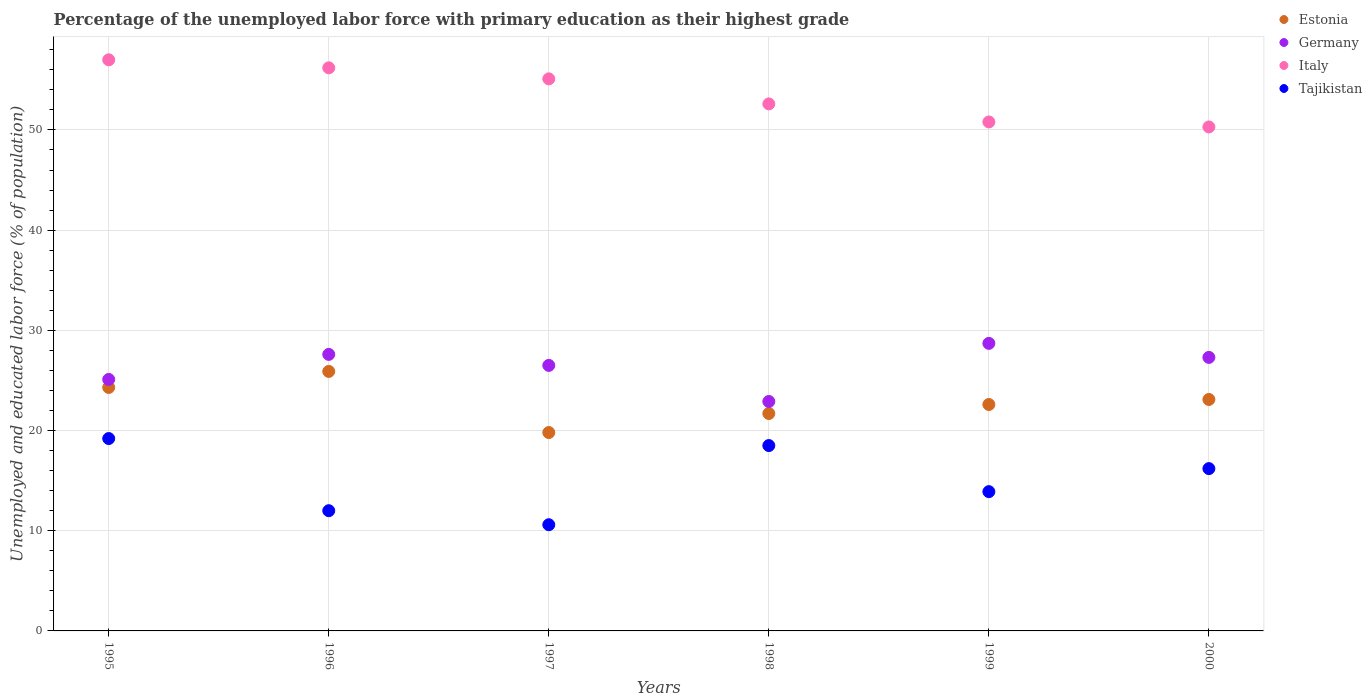How many different coloured dotlines are there?
Provide a succinct answer. 4. Is the number of dotlines equal to the number of legend labels?
Your answer should be compact. Yes. What is the percentage of the unemployed labor force with primary education in Tajikistan in 1999?
Your response must be concise. 13.9. Across all years, what is the maximum percentage of the unemployed labor force with primary education in Tajikistan?
Your response must be concise. 19.2. Across all years, what is the minimum percentage of the unemployed labor force with primary education in Germany?
Make the answer very short. 22.9. In which year was the percentage of the unemployed labor force with primary education in Germany minimum?
Your response must be concise. 1998. What is the total percentage of the unemployed labor force with primary education in Italy in the graph?
Your response must be concise. 322. What is the difference between the percentage of the unemployed labor force with primary education in Germany in 1995 and that in 1997?
Offer a terse response. -1.4. What is the difference between the percentage of the unemployed labor force with primary education in Germany in 1999 and the percentage of the unemployed labor force with primary education in Estonia in 1996?
Make the answer very short. 2.8. What is the average percentage of the unemployed labor force with primary education in Italy per year?
Your response must be concise. 53.67. In the year 2000, what is the difference between the percentage of the unemployed labor force with primary education in Italy and percentage of the unemployed labor force with primary education in Estonia?
Make the answer very short. 27.2. What is the ratio of the percentage of the unemployed labor force with primary education in Tajikistan in 1995 to that in 2000?
Provide a succinct answer. 1.19. What is the difference between the highest and the second highest percentage of the unemployed labor force with primary education in Estonia?
Offer a very short reply. 1.6. What is the difference between the highest and the lowest percentage of the unemployed labor force with primary education in Germany?
Your answer should be compact. 5.8. In how many years, is the percentage of the unemployed labor force with primary education in Tajikistan greater than the average percentage of the unemployed labor force with primary education in Tajikistan taken over all years?
Provide a succinct answer. 3. Is the percentage of the unemployed labor force with primary education in Estonia strictly greater than the percentage of the unemployed labor force with primary education in Tajikistan over the years?
Give a very brief answer. Yes. Is the percentage of the unemployed labor force with primary education in Germany strictly less than the percentage of the unemployed labor force with primary education in Tajikistan over the years?
Provide a succinct answer. No. Does the graph contain any zero values?
Give a very brief answer. No. How are the legend labels stacked?
Ensure brevity in your answer.  Vertical. What is the title of the graph?
Provide a succinct answer. Percentage of the unemployed labor force with primary education as their highest grade. What is the label or title of the X-axis?
Your answer should be very brief. Years. What is the label or title of the Y-axis?
Your response must be concise. Unemployed and educated labor force (% of population). What is the Unemployed and educated labor force (% of population) in Estonia in 1995?
Offer a terse response. 24.3. What is the Unemployed and educated labor force (% of population) in Germany in 1995?
Your answer should be compact. 25.1. What is the Unemployed and educated labor force (% of population) in Tajikistan in 1995?
Provide a short and direct response. 19.2. What is the Unemployed and educated labor force (% of population) in Estonia in 1996?
Your answer should be compact. 25.9. What is the Unemployed and educated labor force (% of population) in Germany in 1996?
Keep it short and to the point. 27.6. What is the Unemployed and educated labor force (% of population) in Italy in 1996?
Provide a short and direct response. 56.2. What is the Unemployed and educated labor force (% of population) in Estonia in 1997?
Offer a very short reply. 19.8. What is the Unemployed and educated labor force (% of population) of Italy in 1997?
Ensure brevity in your answer.  55.1. What is the Unemployed and educated labor force (% of population) of Tajikistan in 1997?
Keep it short and to the point. 10.6. What is the Unemployed and educated labor force (% of population) of Estonia in 1998?
Your answer should be very brief. 21.7. What is the Unemployed and educated labor force (% of population) of Germany in 1998?
Your answer should be compact. 22.9. What is the Unemployed and educated labor force (% of population) of Italy in 1998?
Offer a very short reply. 52.6. What is the Unemployed and educated labor force (% of population) of Estonia in 1999?
Provide a short and direct response. 22.6. What is the Unemployed and educated labor force (% of population) of Germany in 1999?
Ensure brevity in your answer.  28.7. What is the Unemployed and educated labor force (% of population) in Italy in 1999?
Your response must be concise. 50.8. What is the Unemployed and educated labor force (% of population) of Tajikistan in 1999?
Ensure brevity in your answer.  13.9. What is the Unemployed and educated labor force (% of population) of Estonia in 2000?
Make the answer very short. 23.1. What is the Unemployed and educated labor force (% of population) of Germany in 2000?
Ensure brevity in your answer.  27.3. What is the Unemployed and educated labor force (% of population) of Italy in 2000?
Make the answer very short. 50.3. What is the Unemployed and educated labor force (% of population) of Tajikistan in 2000?
Give a very brief answer. 16.2. Across all years, what is the maximum Unemployed and educated labor force (% of population) in Estonia?
Provide a succinct answer. 25.9. Across all years, what is the maximum Unemployed and educated labor force (% of population) in Germany?
Keep it short and to the point. 28.7. Across all years, what is the maximum Unemployed and educated labor force (% of population) in Tajikistan?
Your answer should be compact. 19.2. Across all years, what is the minimum Unemployed and educated labor force (% of population) of Estonia?
Give a very brief answer. 19.8. Across all years, what is the minimum Unemployed and educated labor force (% of population) of Germany?
Provide a short and direct response. 22.9. Across all years, what is the minimum Unemployed and educated labor force (% of population) of Italy?
Provide a short and direct response. 50.3. Across all years, what is the minimum Unemployed and educated labor force (% of population) in Tajikistan?
Make the answer very short. 10.6. What is the total Unemployed and educated labor force (% of population) in Estonia in the graph?
Make the answer very short. 137.4. What is the total Unemployed and educated labor force (% of population) in Germany in the graph?
Provide a short and direct response. 158.1. What is the total Unemployed and educated labor force (% of population) in Italy in the graph?
Keep it short and to the point. 322. What is the total Unemployed and educated labor force (% of population) of Tajikistan in the graph?
Your answer should be compact. 90.4. What is the difference between the Unemployed and educated labor force (% of population) in Estonia in 1995 and that in 1996?
Provide a succinct answer. -1.6. What is the difference between the Unemployed and educated labor force (% of population) in Estonia in 1995 and that in 1997?
Make the answer very short. 4.5. What is the difference between the Unemployed and educated labor force (% of population) of Tajikistan in 1995 and that in 1997?
Give a very brief answer. 8.6. What is the difference between the Unemployed and educated labor force (% of population) in Germany in 1995 and that in 1998?
Offer a very short reply. 2.2. What is the difference between the Unemployed and educated labor force (% of population) in Italy in 1995 and that in 1998?
Your response must be concise. 4.4. What is the difference between the Unemployed and educated labor force (% of population) of Tajikistan in 1995 and that in 1998?
Your response must be concise. 0.7. What is the difference between the Unemployed and educated labor force (% of population) in Italy in 1995 and that in 1999?
Provide a succinct answer. 6.2. What is the difference between the Unemployed and educated labor force (% of population) in Tajikistan in 1995 and that in 1999?
Ensure brevity in your answer.  5.3. What is the difference between the Unemployed and educated labor force (% of population) of Tajikistan in 1995 and that in 2000?
Your response must be concise. 3. What is the difference between the Unemployed and educated labor force (% of population) in Germany in 1996 and that in 1997?
Provide a short and direct response. 1.1. What is the difference between the Unemployed and educated labor force (% of population) of Italy in 1996 and that in 1997?
Provide a succinct answer. 1.1. What is the difference between the Unemployed and educated labor force (% of population) of Germany in 1996 and that in 1998?
Offer a terse response. 4.7. What is the difference between the Unemployed and educated labor force (% of population) in Estonia in 1996 and that in 1999?
Provide a short and direct response. 3.3. What is the difference between the Unemployed and educated labor force (% of population) in Germany in 1996 and that in 1999?
Offer a very short reply. -1.1. What is the difference between the Unemployed and educated labor force (% of population) in Estonia in 1996 and that in 2000?
Provide a short and direct response. 2.8. What is the difference between the Unemployed and educated labor force (% of population) of Italy in 1996 and that in 2000?
Offer a terse response. 5.9. What is the difference between the Unemployed and educated labor force (% of population) of Estonia in 1997 and that in 1998?
Provide a short and direct response. -1.9. What is the difference between the Unemployed and educated labor force (% of population) of Germany in 1997 and that in 1998?
Offer a very short reply. 3.6. What is the difference between the Unemployed and educated labor force (% of population) of Italy in 1997 and that in 1998?
Your answer should be very brief. 2.5. What is the difference between the Unemployed and educated labor force (% of population) of Estonia in 1997 and that in 1999?
Make the answer very short. -2.8. What is the difference between the Unemployed and educated labor force (% of population) in Germany in 1997 and that in 1999?
Give a very brief answer. -2.2. What is the difference between the Unemployed and educated labor force (% of population) in Tajikistan in 1997 and that in 1999?
Keep it short and to the point. -3.3. What is the difference between the Unemployed and educated labor force (% of population) in Germany in 1997 and that in 2000?
Offer a terse response. -0.8. What is the difference between the Unemployed and educated labor force (% of population) of Germany in 1998 and that in 1999?
Your answer should be very brief. -5.8. What is the difference between the Unemployed and educated labor force (% of population) of Estonia in 1998 and that in 2000?
Your answer should be compact. -1.4. What is the difference between the Unemployed and educated labor force (% of population) in Germany in 1999 and that in 2000?
Keep it short and to the point. 1.4. What is the difference between the Unemployed and educated labor force (% of population) in Italy in 1999 and that in 2000?
Give a very brief answer. 0.5. What is the difference between the Unemployed and educated labor force (% of population) in Estonia in 1995 and the Unemployed and educated labor force (% of population) in Germany in 1996?
Offer a very short reply. -3.3. What is the difference between the Unemployed and educated labor force (% of population) of Estonia in 1995 and the Unemployed and educated labor force (% of population) of Italy in 1996?
Keep it short and to the point. -31.9. What is the difference between the Unemployed and educated labor force (% of population) of Estonia in 1995 and the Unemployed and educated labor force (% of population) of Tajikistan in 1996?
Offer a terse response. 12.3. What is the difference between the Unemployed and educated labor force (% of population) of Germany in 1995 and the Unemployed and educated labor force (% of population) of Italy in 1996?
Offer a terse response. -31.1. What is the difference between the Unemployed and educated labor force (% of population) in Estonia in 1995 and the Unemployed and educated labor force (% of population) in Germany in 1997?
Offer a terse response. -2.2. What is the difference between the Unemployed and educated labor force (% of population) of Estonia in 1995 and the Unemployed and educated labor force (% of population) of Italy in 1997?
Offer a terse response. -30.8. What is the difference between the Unemployed and educated labor force (% of population) of Germany in 1995 and the Unemployed and educated labor force (% of population) of Tajikistan in 1997?
Make the answer very short. 14.5. What is the difference between the Unemployed and educated labor force (% of population) of Italy in 1995 and the Unemployed and educated labor force (% of population) of Tajikistan in 1997?
Your answer should be very brief. 46.4. What is the difference between the Unemployed and educated labor force (% of population) of Estonia in 1995 and the Unemployed and educated labor force (% of population) of Italy in 1998?
Provide a short and direct response. -28.3. What is the difference between the Unemployed and educated labor force (% of population) in Germany in 1995 and the Unemployed and educated labor force (% of population) in Italy in 1998?
Give a very brief answer. -27.5. What is the difference between the Unemployed and educated labor force (% of population) of Germany in 1995 and the Unemployed and educated labor force (% of population) of Tajikistan in 1998?
Offer a terse response. 6.6. What is the difference between the Unemployed and educated labor force (% of population) in Italy in 1995 and the Unemployed and educated labor force (% of population) in Tajikistan in 1998?
Keep it short and to the point. 38.5. What is the difference between the Unemployed and educated labor force (% of population) in Estonia in 1995 and the Unemployed and educated labor force (% of population) in Germany in 1999?
Keep it short and to the point. -4.4. What is the difference between the Unemployed and educated labor force (% of population) in Estonia in 1995 and the Unemployed and educated labor force (% of population) in Italy in 1999?
Your answer should be very brief. -26.5. What is the difference between the Unemployed and educated labor force (% of population) of Estonia in 1995 and the Unemployed and educated labor force (% of population) of Tajikistan in 1999?
Your response must be concise. 10.4. What is the difference between the Unemployed and educated labor force (% of population) of Germany in 1995 and the Unemployed and educated labor force (% of population) of Italy in 1999?
Provide a succinct answer. -25.7. What is the difference between the Unemployed and educated labor force (% of population) of Italy in 1995 and the Unemployed and educated labor force (% of population) of Tajikistan in 1999?
Provide a short and direct response. 43.1. What is the difference between the Unemployed and educated labor force (% of population) of Estonia in 1995 and the Unemployed and educated labor force (% of population) of Germany in 2000?
Your answer should be compact. -3. What is the difference between the Unemployed and educated labor force (% of population) of Estonia in 1995 and the Unemployed and educated labor force (% of population) of Italy in 2000?
Keep it short and to the point. -26. What is the difference between the Unemployed and educated labor force (% of population) in Germany in 1995 and the Unemployed and educated labor force (% of population) in Italy in 2000?
Your answer should be very brief. -25.2. What is the difference between the Unemployed and educated labor force (% of population) of Italy in 1995 and the Unemployed and educated labor force (% of population) of Tajikistan in 2000?
Ensure brevity in your answer.  40.8. What is the difference between the Unemployed and educated labor force (% of population) of Estonia in 1996 and the Unemployed and educated labor force (% of population) of Italy in 1997?
Your answer should be compact. -29.2. What is the difference between the Unemployed and educated labor force (% of population) of Germany in 1996 and the Unemployed and educated labor force (% of population) of Italy in 1997?
Offer a very short reply. -27.5. What is the difference between the Unemployed and educated labor force (% of population) in Italy in 1996 and the Unemployed and educated labor force (% of population) in Tajikistan in 1997?
Offer a very short reply. 45.6. What is the difference between the Unemployed and educated labor force (% of population) in Estonia in 1996 and the Unemployed and educated labor force (% of population) in Italy in 1998?
Your answer should be compact. -26.7. What is the difference between the Unemployed and educated labor force (% of population) of Estonia in 1996 and the Unemployed and educated labor force (% of population) of Tajikistan in 1998?
Ensure brevity in your answer.  7.4. What is the difference between the Unemployed and educated labor force (% of population) in Germany in 1996 and the Unemployed and educated labor force (% of population) in Italy in 1998?
Your answer should be compact. -25. What is the difference between the Unemployed and educated labor force (% of population) in Germany in 1996 and the Unemployed and educated labor force (% of population) in Tajikistan in 1998?
Make the answer very short. 9.1. What is the difference between the Unemployed and educated labor force (% of population) in Italy in 1996 and the Unemployed and educated labor force (% of population) in Tajikistan in 1998?
Offer a terse response. 37.7. What is the difference between the Unemployed and educated labor force (% of population) in Estonia in 1996 and the Unemployed and educated labor force (% of population) in Germany in 1999?
Make the answer very short. -2.8. What is the difference between the Unemployed and educated labor force (% of population) in Estonia in 1996 and the Unemployed and educated labor force (% of population) in Italy in 1999?
Provide a succinct answer. -24.9. What is the difference between the Unemployed and educated labor force (% of population) of Germany in 1996 and the Unemployed and educated labor force (% of population) of Italy in 1999?
Provide a short and direct response. -23.2. What is the difference between the Unemployed and educated labor force (% of population) of Germany in 1996 and the Unemployed and educated labor force (% of population) of Tajikistan in 1999?
Give a very brief answer. 13.7. What is the difference between the Unemployed and educated labor force (% of population) in Italy in 1996 and the Unemployed and educated labor force (% of population) in Tajikistan in 1999?
Your response must be concise. 42.3. What is the difference between the Unemployed and educated labor force (% of population) of Estonia in 1996 and the Unemployed and educated labor force (% of population) of Germany in 2000?
Offer a terse response. -1.4. What is the difference between the Unemployed and educated labor force (% of population) in Estonia in 1996 and the Unemployed and educated labor force (% of population) in Italy in 2000?
Give a very brief answer. -24.4. What is the difference between the Unemployed and educated labor force (% of population) in Germany in 1996 and the Unemployed and educated labor force (% of population) in Italy in 2000?
Provide a succinct answer. -22.7. What is the difference between the Unemployed and educated labor force (% of population) of Italy in 1996 and the Unemployed and educated labor force (% of population) of Tajikistan in 2000?
Keep it short and to the point. 40. What is the difference between the Unemployed and educated labor force (% of population) in Estonia in 1997 and the Unemployed and educated labor force (% of population) in Italy in 1998?
Your response must be concise. -32.8. What is the difference between the Unemployed and educated labor force (% of population) of Germany in 1997 and the Unemployed and educated labor force (% of population) of Italy in 1998?
Your answer should be compact. -26.1. What is the difference between the Unemployed and educated labor force (% of population) of Italy in 1997 and the Unemployed and educated labor force (% of population) of Tajikistan in 1998?
Provide a short and direct response. 36.6. What is the difference between the Unemployed and educated labor force (% of population) in Estonia in 1997 and the Unemployed and educated labor force (% of population) in Italy in 1999?
Provide a succinct answer. -31. What is the difference between the Unemployed and educated labor force (% of population) in Germany in 1997 and the Unemployed and educated labor force (% of population) in Italy in 1999?
Make the answer very short. -24.3. What is the difference between the Unemployed and educated labor force (% of population) in Italy in 1997 and the Unemployed and educated labor force (% of population) in Tajikistan in 1999?
Keep it short and to the point. 41.2. What is the difference between the Unemployed and educated labor force (% of population) in Estonia in 1997 and the Unemployed and educated labor force (% of population) in Germany in 2000?
Give a very brief answer. -7.5. What is the difference between the Unemployed and educated labor force (% of population) in Estonia in 1997 and the Unemployed and educated labor force (% of population) in Italy in 2000?
Provide a succinct answer. -30.5. What is the difference between the Unemployed and educated labor force (% of population) of Estonia in 1997 and the Unemployed and educated labor force (% of population) of Tajikistan in 2000?
Give a very brief answer. 3.6. What is the difference between the Unemployed and educated labor force (% of population) in Germany in 1997 and the Unemployed and educated labor force (% of population) in Italy in 2000?
Provide a short and direct response. -23.8. What is the difference between the Unemployed and educated labor force (% of population) in Italy in 1997 and the Unemployed and educated labor force (% of population) in Tajikistan in 2000?
Provide a short and direct response. 38.9. What is the difference between the Unemployed and educated labor force (% of population) in Estonia in 1998 and the Unemployed and educated labor force (% of population) in Germany in 1999?
Offer a very short reply. -7. What is the difference between the Unemployed and educated labor force (% of population) of Estonia in 1998 and the Unemployed and educated labor force (% of population) of Italy in 1999?
Offer a terse response. -29.1. What is the difference between the Unemployed and educated labor force (% of population) of Estonia in 1998 and the Unemployed and educated labor force (% of population) of Tajikistan in 1999?
Offer a terse response. 7.8. What is the difference between the Unemployed and educated labor force (% of population) in Germany in 1998 and the Unemployed and educated labor force (% of population) in Italy in 1999?
Make the answer very short. -27.9. What is the difference between the Unemployed and educated labor force (% of population) in Germany in 1998 and the Unemployed and educated labor force (% of population) in Tajikistan in 1999?
Provide a short and direct response. 9. What is the difference between the Unemployed and educated labor force (% of population) in Italy in 1998 and the Unemployed and educated labor force (% of population) in Tajikistan in 1999?
Provide a short and direct response. 38.7. What is the difference between the Unemployed and educated labor force (% of population) in Estonia in 1998 and the Unemployed and educated labor force (% of population) in Italy in 2000?
Make the answer very short. -28.6. What is the difference between the Unemployed and educated labor force (% of population) of Germany in 1998 and the Unemployed and educated labor force (% of population) of Italy in 2000?
Provide a short and direct response. -27.4. What is the difference between the Unemployed and educated labor force (% of population) in Italy in 1998 and the Unemployed and educated labor force (% of population) in Tajikistan in 2000?
Ensure brevity in your answer.  36.4. What is the difference between the Unemployed and educated labor force (% of population) in Estonia in 1999 and the Unemployed and educated labor force (% of population) in Germany in 2000?
Provide a short and direct response. -4.7. What is the difference between the Unemployed and educated labor force (% of population) in Estonia in 1999 and the Unemployed and educated labor force (% of population) in Italy in 2000?
Give a very brief answer. -27.7. What is the difference between the Unemployed and educated labor force (% of population) in Germany in 1999 and the Unemployed and educated labor force (% of population) in Italy in 2000?
Your answer should be compact. -21.6. What is the difference between the Unemployed and educated labor force (% of population) in Italy in 1999 and the Unemployed and educated labor force (% of population) in Tajikistan in 2000?
Provide a succinct answer. 34.6. What is the average Unemployed and educated labor force (% of population) of Estonia per year?
Provide a succinct answer. 22.9. What is the average Unemployed and educated labor force (% of population) in Germany per year?
Make the answer very short. 26.35. What is the average Unemployed and educated labor force (% of population) of Italy per year?
Your answer should be compact. 53.67. What is the average Unemployed and educated labor force (% of population) in Tajikistan per year?
Ensure brevity in your answer.  15.07. In the year 1995, what is the difference between the Unemployed and educated labor force (% of population) of Estonia and Unemployed and educated labor force (% of population) of Germany?
Your answer should be compact. -0.8. In the year 1995, what is the difference between the Unemployed and educated labor force (% of population) in Estonia and Unemployed and educated labor force (% of population) in Italy?
Your answer should be compact. -32.7. In the year 1995, what is the difference between the Unemployed and educated labor force (% of population) of Estonia and Unemployed and educated labor force (% of population) of Tajikistan?
Provide a short and direct response. 5.1. In the year 1995, what is the difference between the Unemployed and educated labor force (% of population) of Germany and Unemployed and educated labor force (% of population) of Italy?
Your answer should be very brief. -31.9. In the year 1995, what is the difference between the Unemployed and educated labor force (% of population) in Germany and Unemployed and educated labor force (% of population) in Tajikistan?
Ensure brevity in your answer.  5.9. In the year 1995, what is the difference between the Unemployed and educated labor force (% of population) of Italy and Unemployed and educated labor force (% of population) of Tajikistan?
Provide a short and direct response. 37.8. In the year 1996, what is the difference between the Unemployed and educated labor force (% of population) of Estonia and Unemployed and educated labor force (% of population) of Germany?
Your answer should be very brief. -1.7. In the year 1996, what is the difference between the Unemployed and educated labor force (% of population) of Estonia and Unemployed and educated labor force (% of population) of Italy?
Offer a very short reply. -30.3. In the year 1996, what is the difference between the Unemployed and educated labor force (% of population) in Estonia and Unemployed and educated labor force (% of population) in Tajikistan?
Offer a very short reply. 13.9. In the year 1996, what is the difference between the Unemployed and educated labor force (% of population) of Germany and Unemployed and educated labor force (% of population) of Italy?
Offer a very short reply. -28.6. In the year 1996, what is the difference between the Unemployed and educated labor force (% of population) of Italy and Unemployed and educated labor force (% of population) of Tajikistan?
Ensure brevity in your answer.  44.2. In the year 1997, what is the difference between the Unemployed and educated labor force (% of population) in Estonia and Unemployed and educated labor force (% of population) in Germany?
Keep it short and to the point. -6.7. In the year 1997, what is the difference between the Unemployed and educated labor force (% of population) of Estonia and Unemployed and educated labor force (% of population) of Italy?
Your response must be concise. -35.3. In the year 1997, what is the difference between the Unemployed and educated labor force (% of population) in Estonia and Unemployed and educated labor force (% of population) in Tajikistan?
Your answer should be compact. 9.2. In the year 1997, what is the difference between the Unemployed and educated labor force (% of population) of Germany and Unemployed and educated labor force (% of population) of Italy?
Keep it short and to the point. -28.6. In the year 1997, what is the difference between the Unemployed and educated labor force (% of population) in Germany and Unemployed and educated labor force (% of population) in Tajikistan?
Your response must be concise. 15.9. In the year 1997, what is the difference between the Unemployed and educated labor force (% of population) in Italy and Unemployed and educated labor force (% of population) in Tajikistan?
Your answer should be compact. 44.5. In the year 1998, what is the difference between the Unemployed and educated labor force (% of population) of Estonia and Unemployed and educated labor force (% of population) of Germany?
Your answer should be compact. -1.2. In the year 1998, what is the difference between the Unemployed and educated labor force (% of population) in Estonia and Unemployed and educated labor force (% of population) in Italy?
Offer a terse response. -30.9. In the year 1998, what is the difference between the Unemployed and educated labor force (% of population) of Estonia and Unemployed and educated labor force (% of population) of Tajikistan?
Your response must be concise. 3.2. In the year 1998, what is the difference between the Unemployed and educated labor force (% of population) in Germany and Unemployed and educated labor force (% of population) in Italy?
Offer a terse response. -29.7. In the year 1998, what is the difference between the Unemployed and educated labor force (% of population) in Germany and Unemployed and educated labor force (% of population) in Tajikistan?
Provide a succinct answer. 4.4. In the year 1998, what is the difference between the Unemployed and educated labor force (% of population) in Italy and Unemployed and educated labor force (% of population) in Tajikistan?
Your answer should be very brief. 34.1. In the year 1999, what is the difference between the Unemployed and educated labor force (% of population) in Estonia and Unemployed and educated labor force (% of population) in Italy?
Your response must be concise. -28.2. In the year 1999, what is the difference between the Unemployed and educated labor force (% of population) of Germany and Unemployed and educated labor force (% of population) of Italy?
Offer a terse response. -22.1. In the year 1999, what is the difference between the Unemployed and educated labor force (% of population) in Germany and Unemployed and educated labor force (% of population) in Tajikistan?
Offer a very short reply. 14.8. In the year 1999, what is the difference between the Unemployed and educated labor force (% of population) in Italy and Unemployed and educated labor force (% of population) in Tajikistan?
Provide a succinct answer. 36.9. In the year 2000, what is the difference between the Unemployed and educated labor force (% of population) in Estonia and Unemployed and educated labor force (% of population) in Italy?
Your answer should be compact. -27.2. In the year 2000, what is the difference between the Unemployed and educated labor force (% of population) in Germany and Unemployed and educated labor force (% of population) in Italy?
Provide a succinct answer. -23. In the year 2000, what is the difference between the Unemployed and educated labor force (% of population) of Italy and Unemployed and educated labor force (% of population) of Tajikistan?
Your response must be concise. 34.1. What is the ratio of the Unemployed and educated labor force (% of population) of Estonia in 1995 to that in 1996?
Your answer should be compact. 0.94. What is the ratio of the Unemployed and educated labor force (% of population) of Germany in 1995 to that in 1996?
Make the answer very short. 0.91. What is the ratio of the Unemployed and educated labor force (% of population) of Italy in 1995 to that in 1996?
Make the answer very short. 1.01. What is the ratio of the Unemployed and educated labor force (% of population) of Tajikistan in 1995 to that in 1996?
Ensure brevity in your answer.  1.6. What is the ratio of the Unemployed and educated labor force (% of population) of Estonia in 1995 to that in 1997?
Provide a succinct answer. 1.23. What is the ratio of the Unemployed and educated labor force (% of population) of Germany in 1995 to that in 1997?
Your answer should be very brief. 0.95. What is the ratio of the Unemployed and educated labor force (% of population) of Italy in 1995 to that in 1997?
Give a very brief answer. 1.03. What is the ratio of the Unemployed and educated labor force (% of population) in Tajikistan in 1995 to that in 1997?
Give a very brief answer. 1.81. What is the ratio of the Unemployed and educated labor force (% of population) of Estonia in 1995 to that in 1998?
Give a very brief answer. 1.12. What is the ratio of the Unemployed and educated labor force (% of population) in Germany in 1995 to that in 1998?
Ensure brevity in your answer.  1.1. What is the ratio of the Unemployed and educated labor force (% of population) in Italy in 1995 to that in 1998?
Your response must be concise. 1.08. What is the ratio of the Unemployed and educated labor force (% of population) of Tajikistan in 1995 to that in 1998?
Ensure brevity in your answer.  1.04. What is the ratio of the Unemployed and educated labor force (% of population) in Estonia in 1995 to that in 1999?
Ensure brevity in your answer.  1.08. What is the ratio of the Unemployed and educated labor force (% of population) of Germany in 1995 to that in 1999?
Ensure brevity in your answer.  0.87. What is the ratio of the Unemployed and educated labor force (% of population) of Italy in 1995 to that in 1999?
Make the answer very short. 1.12. What is the ratio of the Unemployed and educated labor force (% of population) in Tajikistan in 1995 to that in 1999?
Keep it short and to the point. 1.38. What is the ratio of the Unemployed and educated labor force (% of population) in Estonia in 1995 to that in 2000?
Offer a very short reply. 1.05. What is the ratio of the Unemployed and educated labor force (% of population) of Germany in 1995 to that in 2000?
Your answer should be compact. 0.92. What is the ratio of the Unemployed and educated labor force (% of population) in Italy in 1995 to that in 2000?
Offer a very short reply. 1.13. What is the ratio of the Unemployed and educated labor force (% of population) in Tajikistan in 1995 to that in 2000?
Provide a short and direct response. 1.19. What is the ratio of the Unemployed and educated labor force (% of population) in Estonia in 1996 to that in 1997?
Offer a very short reply. 1.31. What is the ratio of the Unemployed and educated labor force (% of population) in Germany in 1996 to that in 1997?
Keep it short and to the point. 1.04. What is the ratio of the Unemployed and educated labor force (% of population) in Tajikistan in 1996 to that in 1997?
Provide a succinct answer. 1.13. What is the ratio of the Unemployed and educated labor force (% of population) of Estonia in 1996 to that in 1998?
Make the answer very short. 1.19. What is the ratio of the Unemployed and educated labor force (% of population) of Germany in 1996 to that in 1998?
Offer a very short reply. 1.21. What is the ratio of the Unemployed and educated labor force (% of population) of Italy in 1996 to that in 1998?
Your response must be concise. 1.07. What is the ratio of the Unemployed and educated labor force (% of population) of Tajikistan in 1996 to that in 1998?
Your answer should be very brief. 0.65. What is the ratio of the Unemployed and educated labor force (% of population) in Estonia in 1996 to that in 1999?
Provide a succinct answer. 1.15. What is the ratio of the Unemployed and educated labor force (% of population) of Germany in 1996 to that in 1999?
Offer a terse response. 0.96. What is the ratio of the Unemployed and educated labor force (% of population) in Italy in 1996 to that in 1999?
Make the answer very short. 1.11. What is the ratio of the Unemployed and educated labor force (% of population) of Tajikistan in 1996 to that in 1999?
Your response must be concise. 0.86. What is the ratio of the Unemployed and educated labor force (% of population) in Estonia in 1996 to that in 2000?
Give a very brief answer. 1.12. What is the ratio of the Unemployed and educated labor force (% of population) of Germany in 1996 to that in 2000?
Ensure brevity in your answer.  1.01. What is the ratio of the Unemployed and educated labor force (% of population) in Italy in 1996 to that in 2000?
Your answer should be very brief. 1.12. What is the ratio of the Unemployed and educated labor force (% of population) of Tajikistan in 1996 to that in 2000?
Offer a very short reply. 0.74. What is the ratio of the Unemployed and educated labor force (% of population) of Estonia in 1997 to that in 1998?
Your answer should be compact. 0.91. What is the ratio of the Unemployed and educated labor force (% of population) of Germany in 1997 to that in 1998?
Provide a succinct answer. 1.16. What is the ratio of the Unemployed and educated labor force (% of population) in Italy in 1997 to that in 1998?
Make the answer very short. 1.05. What is the ratio of the Unemployed and educated labor force (% of population) in Tajikistan in 1997 to that in 1998?
Provide a short and direct response. 0.57. What is the ratio of the Unemployed and educated labor force (% of population) in Estonia in 1997 to that in 1999?
Ensure brevity in your answer.  0.88. What is the ratio of the Unemployed and educated labor force (% of population) in Germany in 1997 to that in 1999?
Make the answer very short. 0.92. What is the ratio of the Unemployed and educated labor force (% of population) of Italy in 1997 to that in 1999?
Provide a succinct answer. 1.08. What is the ratio of the Unemployed and educated labor force (% of population) of Tajikistan in 1997 to that in 1999?
Your response must be concise. 0.76. What is the ratio of the Unemployed and educated labor force (% of population) of Estonia in 1997 to that in 2000?
Offer a very short reply. 0.86. What is the ratio of the Unemployed and educated labor force (% of population) in Germany in 1997 to that in 2000?
Your answer should be very brief. 0.97. What is the ratio of the Unemployed and educated labor force (% of population) of Italy in 1997 to that in 2000?
Your answer should be very brief. 1.1. What is the ratio of the Unemployed and educated labor force (% of population) of Tajikistan in 1997 to that in 2000?
Offer a terse response. 0.65. What is the ratio of the Unemployed and educated labor force (% of population) in Estonia in 1998 to that in 1999?
Ensure brevity in your answer.  0.96. What is the ratio of the Unemployed and educated labor force (% of population) of Germany in 1998 to that in 1999?
Keep it short and to the point. 0.8. What is the ratio of the Unemployed and educated labor force (% of population) in Italy in 1998 to that in 1999?
Offer a terse response. 1.04. What is the ratio of the Unemployed and educated labor force (% of population) in Tajikistan in 1998 to that in 1999?
Ensure brevity in your answer.  1.33. What is the ratio of the Unemployed and educated labor force (% of population) of Estonia in 1998 to that in 2000?
Your answer should be compact. 0.94. What is the ratio of the Unemployed and educated labor force (% of population) in Germany in 1998 to that in 2000?
Make the answer very short. 0.84. What is the ratio of the Unemployed and educated labor force (% of population) of Italy in 1998 to that in 2000?
Ensure brevity in your answer.  1.05. What is the ratio of the Unemployed and educated labor force (% of population) of Tajikistan in 1998 to that in 2000?
Keep it short and to the point. 1.14. What is the ratio of the Unemployed and educated labor force (% of population) of Estonia in 1999 to that in 2000?
Keep it short and to the point. 0.98. What is the ratio of the Unemployed and educated labor force (% of population) in Germany in 1999 to that in 2000?
Offer a very short reply. 1.05. What is the ratio of the Unemployed and educated labor force (% of population) in Italy in 1999 to that in 2000?
Give a very brief answer. 1.01. What is the ratio of the Unemployed and educated labor force (% of population) in Tajikistan in 1999 to that in 2000?
Provide a short and direct response. 0.86. What is the difference between the highest and the second highest Unemployed and educated labor force (% of population) in Estonia?
Make the answer very short. 1.6. What is the difference between the highest and the second highest Unemployed and educated labor force (% of population) of Germany?
Make the answer very short. 1.1. What is the difference between the highest and the lowest Unemployed and educated labor force (% of population) of Germany?
Give a very brief answer. 5.8. What is the difference between the highest and the lowest Unemployed and educated labor force (% of population) in Italy?
Offer a very short reply. 6.7. What is the difference between the highest and the lowest Unemployed and educated labor force (% of population) of Tajikistan?
Your response must be concise. 8.6. 